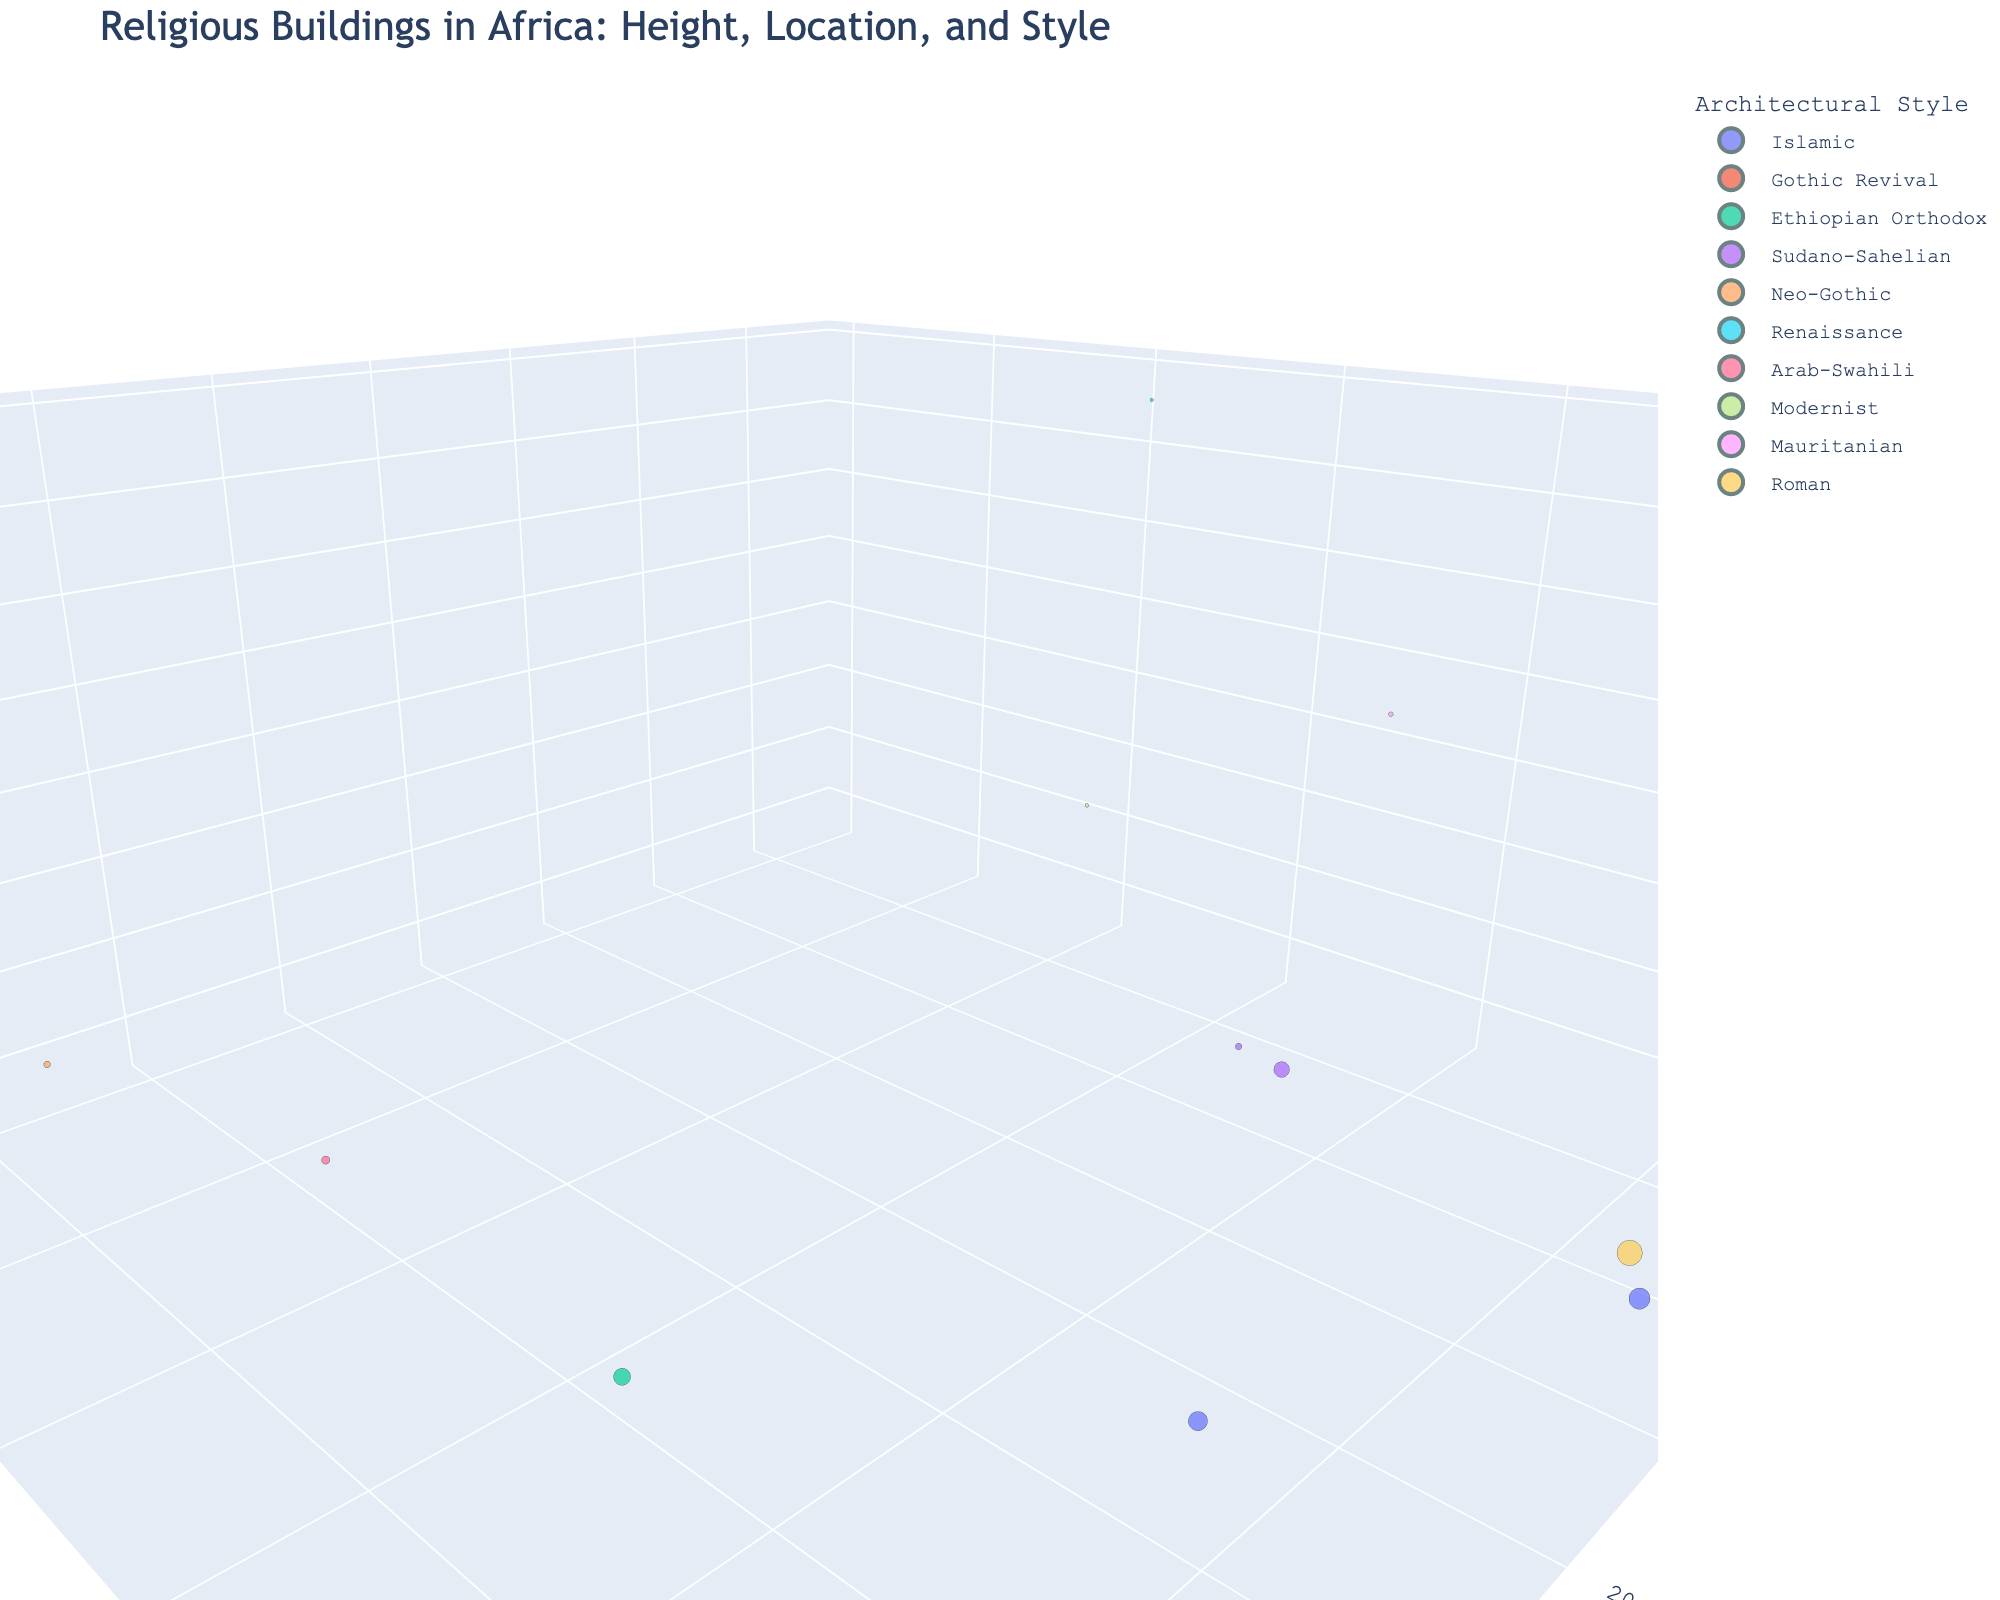What is the geographical location of the tallest building on the plot? Identify the 3D scatter plot point which has the greatest 'Height (m)' value. The tallest building is the Basilica of Our Lady of Peace, and its coordinates are (Longitude, Latitude) = (-5.2892, 6.8276).
Answer: (-5.2892, 6.8276) Which architectural style has the highest average building height? Calculate the average height for each architectural style by summing the heights and dividing by the number of data points in that style. The average height for each style is: Islamic (35m), Gothic Revival (45m), Ethiopian Orthodox (12m), Sudano-Sahelian (17m), Neo-Gothic (40m), Renaissance (158m), Arab-Swahili (15m), Modernist (64m), Mauritanian (87m), Roman (41m). Renaissance has the highest average height.
Answer: Renaissance How many buildings are there in total on the plot? Count the total number of data points (buildings) in the 3D scatter plot. There are 12 buildings shown.
Answer: 12 Which building has the oldest age and what is its architectural style? Identify the building with the largest 'Age (years)' value from the plot. The oldest building is the Amphitheatre of El Jem with an age of 1821 years, and its style is Roman.
Answer: Amphitheatre of El Jem, Roman Compare the heights of the buildings belonging to the two Islamic architectural styles on the plot. Which one is taller? Compare the height values of 'Great Mosque of Kairouan' (32m) and 'Al-Azhar Mosque' (38m). Al-Azhar Mosque is taller.
Answer: Al-Azhar Mosque Which two buildings are closest in height to the Great Mosque of Djenné? Identify the 'Height (m)' of the Great Mosque of Djenné (16m). Then find the two buildings with heights closest to 16m, in this case, Djinguereber Mosque (18m) and Lalibela Rock-Hewn Churches (12m).
Answer: Djinguereber Mosque and Lalibela Rock-Hewn Churches How many buildings have a height greater than 40 meters? Count the data points in the 3D scatter plot where the 'Height (m)' value exceeds 40. There are 4 such buildings: St. George's Cathedral Port Louis, Cathedral of St. Mary and St. Anne, Basilica of Our Lady of Peace, and St. Paul’s Cathedral Abidjan.
Answer: 4 Which building is located at the furthest eastward longitude? Identify the building with the greatest 'Longitude' value on the plot. The building is St. George’s Cathedral Port Louis with a longitude of 57.4989.
Answer: St. George’s Cathedral Port Louis What is the average height of the buildings categorized under the Sudano-Sahelian architectural style? Calculate the average building height for the Sudano-Sahelian style by summing the heights (18m and 16m) and dividing by the number (2). Average height = (18 + 16) / 2 = 17 meters.
Answer: 17 meters Which building is the most centrally located in terms of latitude and longitude? Calculate the average of the 'Latitude' and 'Longitude' values, then identify the building closest to these average values. The closest building to the average geographical location (Latitude ~12.9, Longitude ~11.7) is the Djinguereber Mosque.
Answer: Djinguereber Mosque 